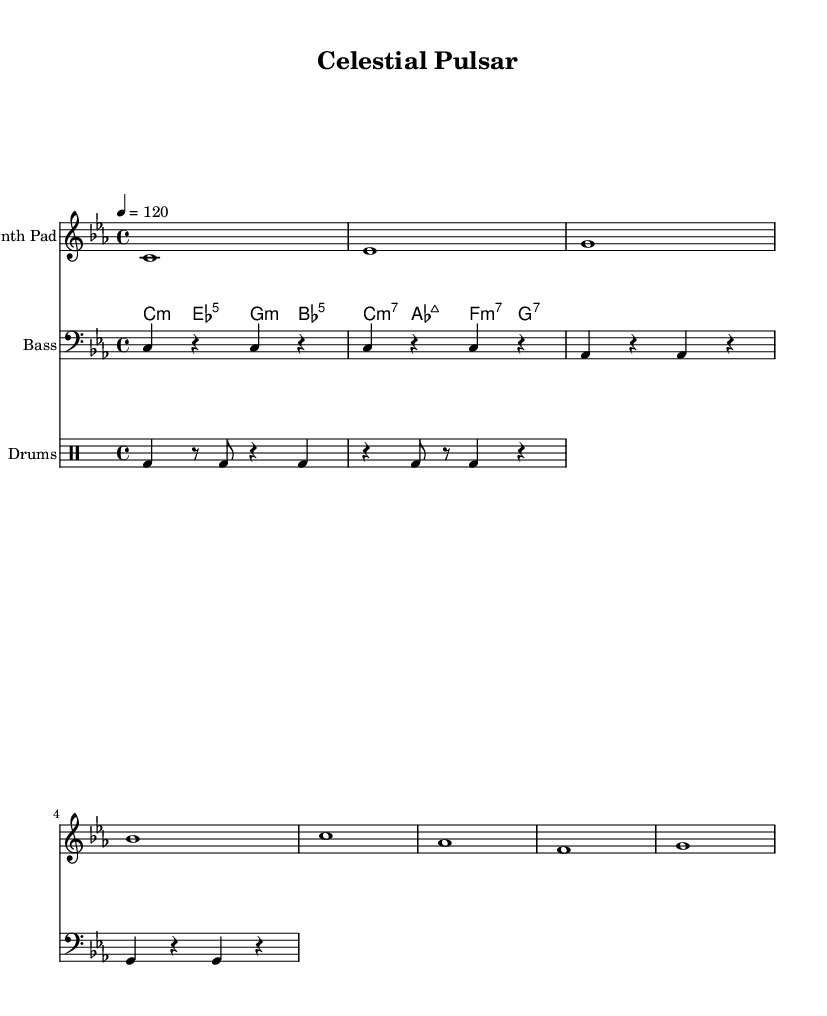What is the key signature of this music? The key signature is C minor, which has three flats (B♭, E♭, and A♭) indicated at the beginning.
Answer: C minor What is the time signature of this piece? The time signature is indicated as 4/4, meaning there are four beats in each measure and the quarter note receives one beat.
Answer: 4/4 What is the tempo marking for this piece? The tempo marking is given as 4 = 120, indicating that the quarter note should be played at 120 beats per minute.
Answer: 120 How many measures are in the synth pad part? Counting the measures in the synth pad part, there are a total of 8 measures present.
Answer: 8 What is the rhythmic pattern of the bass part? The bass part consists of alternating half notes and rests, where each note is played on beat one and rests on beat two of each measure.
Answer: Alternating half notes and rests Which type of chords is used in the synth chords section? The chords in the synth chords section include minor, major, and seventh chords, creating a rich harmonic texture typical of ambient house music.
Answer: Minor, major, seventh What instrument groups are featured in this composition? The composition features the synth pad, bass, and drums, providing a balance of harmonic, melodic, and rhythmic elements characteristic of house music.
Answer: Synth pad, bass, drums 